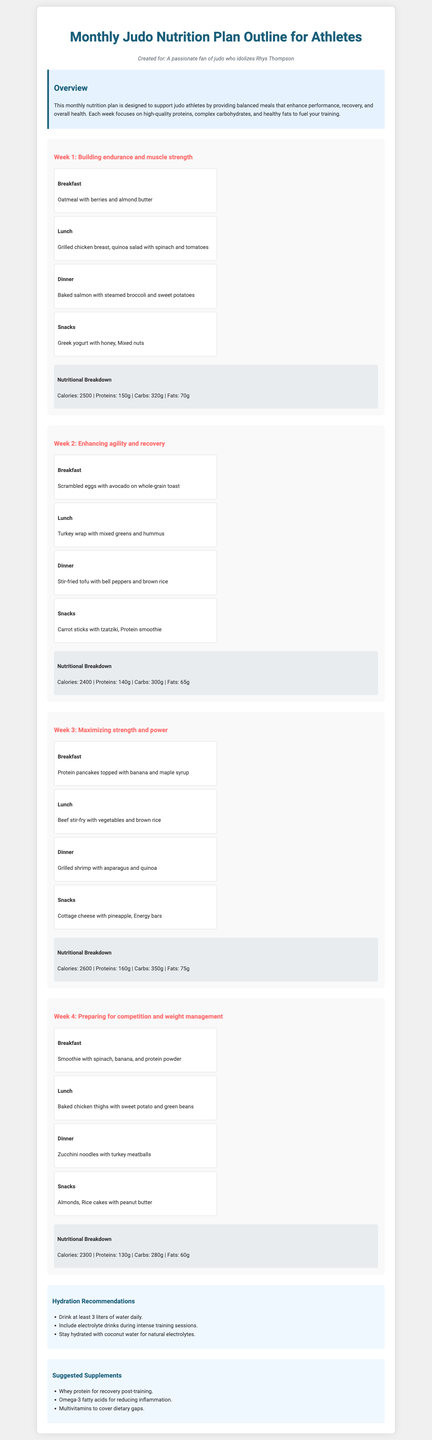What is the main goal of the nutrition plan? The nutrition plan is designed to support judo athletes by providing balanced meals that enhance performance, recovery, and overall health.
Answer: Support judo athletes How many calories are recommended in Week 3? The nutritional breakdown for Week 3 indicates a total of 2600 calories.
Answer: 2600 Which meal includes Greek yogurt? Greek yogurt is included as a snack in Week 1.
Answer: Snack in Week 1 What is the protein recommendation for Week 2? The nutritional breakdown for Week 2 shows 140 grams of protein.
Answer: 140g What type of supplement is suggested for reducing inflammation? Omega-3 fatty acids are recommended for reducing inflammation.
Answer: Omega-3 fatty acids What meal is recommended for dinner in Week 4? The dinner suggestion for Week 4 is zucchini noodles with turkey meatballs.
Answer: Zucchini noodles with turkey meatballs How many liters of water should be consumed daily? The recommendation states to drink at least 3 liters of water daily.
Answer: 3 liters What is the focus of Week 1's meal plan? Week 1 focuses on building endurance and muscle strength.
Answer: Building endurance and muscle strength Which snack is included in Week 2? Carrot sticks with tzatziki is a snack suggestion in Week 2.
Answer: Carrot sticks with tzatziki 